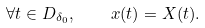<formula> <loc_0><loc_0><loc_500><loc_500>\forall t \in D _ { \delta _ { 0 } } , \quad x ( t ) = X ( t ) .</formula> 